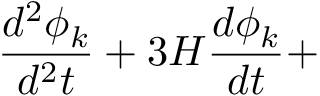Convert formula to latex. <formula><loc_0><loc_0><loc_500><loc_500>\frac { d ^ { 2 } \phi _ { k } } { d ^ { 2 } t } + 3 H \frac { d \phi _ { k } } { d t } +</formula> 